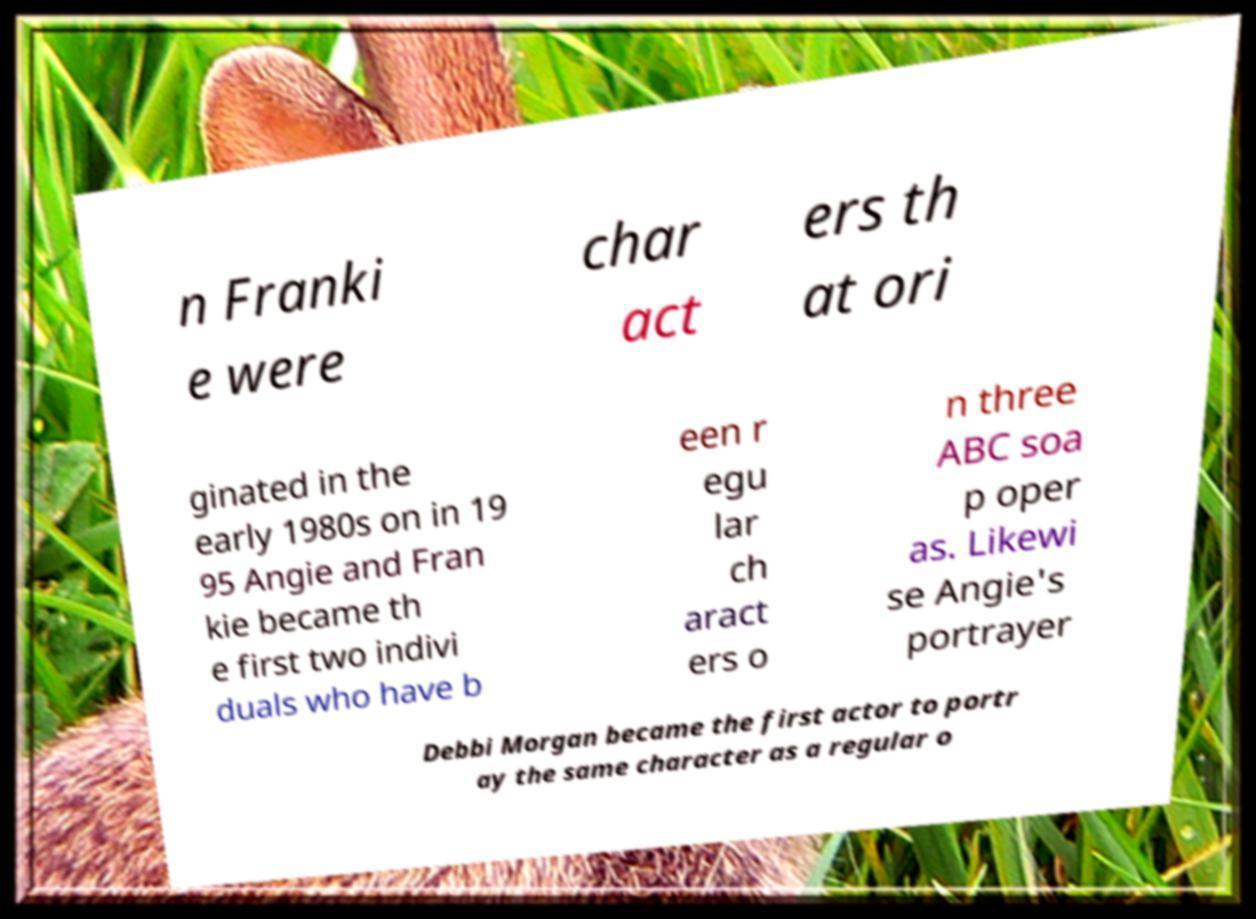There's text embedded in this image that I need extracted. Can you transcribe it verbatim? n Franki e were char act ers th at ori ginated in the early 1980s on in 19 95 Angie and Fran kie became th e first two indivi duals who have b een r egu lar ch aract ers o n three ABC soa p oper as. Likewi se Angie's portrayer Debbi Morgan became the first actor to portr ay the same character as a regular o 